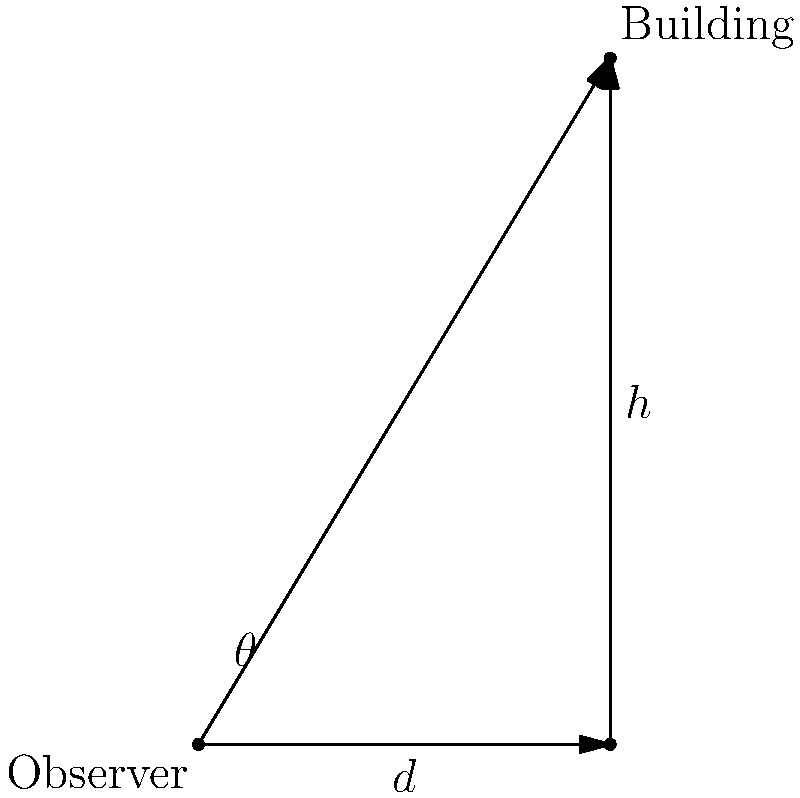A famous Brooklyn skyscraper stands 500 feet tall. As a tour guide, you want to find the optimal viewing angle for your group to appreciate the building's architecture. If you're standing 300 feet away from the base of the building, at what angle (in degrees) should you tilt your head up to view the top of the skyscraper for the best perspective? Express your answer in terms of the inverse tangent function. Let's approach this step-by-step:

1) First, let's identify the known quantities:
   - Height of the building (h) = 500 feet
   - Distance from the base (d) = 300 feet

2) We need to find the angle (θ) between the ground and the line of sight to the top of the building.

3) This scenario forms a right-angled triangle, where:
   - The adjacent side is the distance from the observer to the base (300 feet)
   - The opposite side is the height of the building (500 feet)
   - The angle we're looking for is formed between the adjacent side and the hypotenuse

4) In trigonometry, the tangent of an angle is defined as the ratio of the opposite side to the adjacent side:

   $$\tan(\theta) = \frac{\text{opposite}}{\text{adjacent}} = \frac{h}{d} = \frac{500}{300}$$

5) To find θ, we need to use the inverse tangent function (arctan or $\tan^{-1}$):

   $$\theta = \tan^{-1}\left(\frac{500}{300}\right)$$

6) This gives us the angle in radians. The question asks for the answer in terms of the inverse tangent function, so this is our final answer.

Note: If we were to calculate this, it would be approximately 59.04 degrees.
Answer: $\tan^{-1}\left(\frac{500}{300}\right)$ 